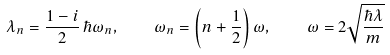<formula> <loc_0><loc_0><loc_500><loc_500>\lambda _ { n } = \frac { 1 - i } { 2 } \, \hbar { \omega } _ { n } , \quad \omega _ { n } = \left ( n + \frac { 1 } { 2 } \right ) \omega , \quad \omega = 2 \sqrt { \frac { \hbar { \lambda } } { m } }</formula> 